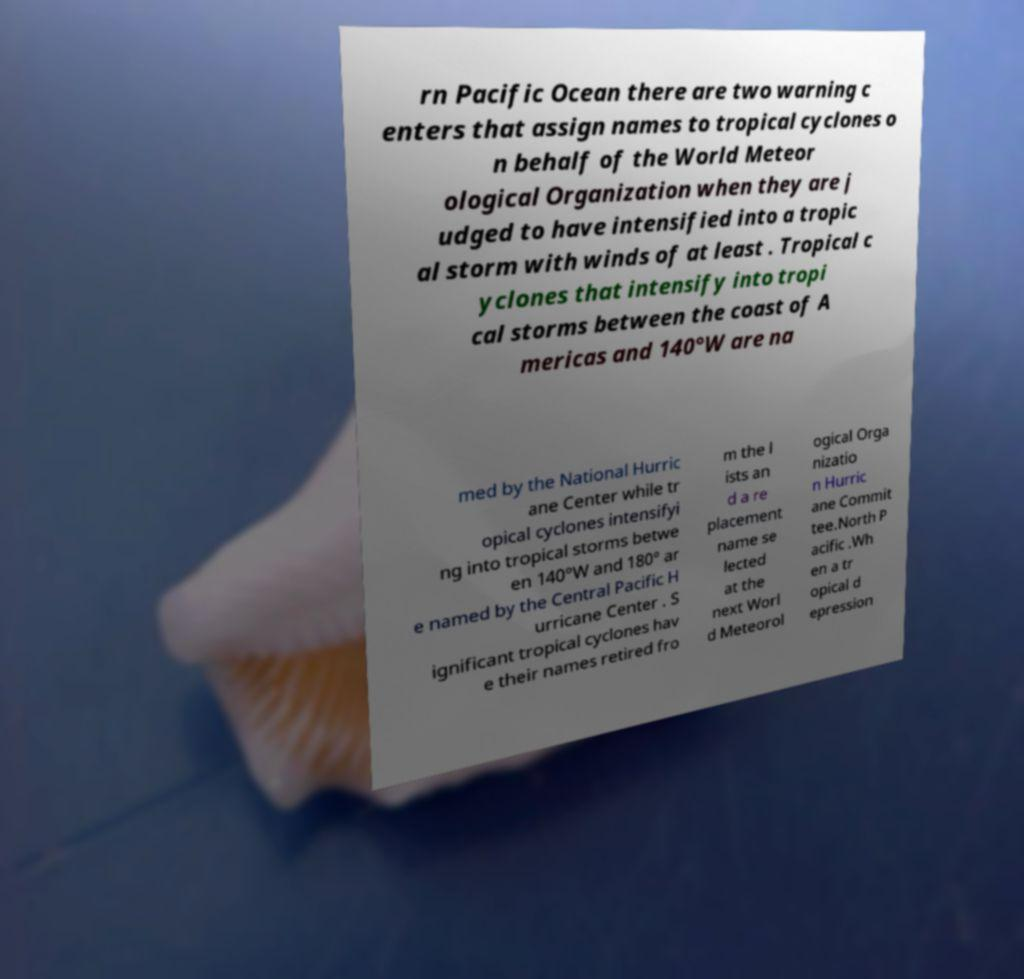I need the written content from this picture converted into text. Can you do that? rn Pacific Ocean there are two warning c enters that assign names to tropical cyclones o n behalf of the World Meteor ological Organization when they are j udged to have intensified into a tropic al storm with winds of at least . Tropical c yclones that intensify into tropi cal storms between the coast of A mericas and 140°W are na med by the National Hurric ane Center while tr opical cyclones intensifyi ng into tropical storms betwe en 140°W and 180° ar e named by the Central Pacific H urricane Center . S ignificant tropical cyclones hav e their names retired fro m the l ists an d a re placement name se lected at the next Worl d Meteorol ogical Orga nizatio n Hurric ane Commit tee.North P acific .Wh en a tr opical d epression 